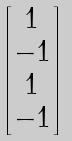Convert formula to latex. <formula><loc_0><loc_0><loc_500><loc_500>\begin{bmatrix} 1 \\ - 1 \\ 1 \\ - 1 \end{bmatrix}</formula> 